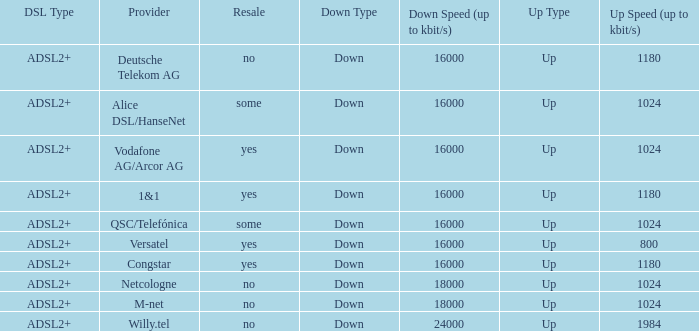Who are all of the telecom providers for which the upload rate is 1024 kbits and the resale category is yes? Vodafone AG/Arcor AG. 